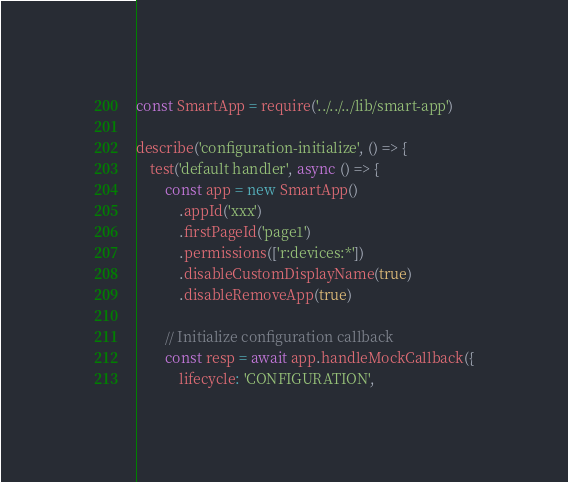Convert code to text. <code><loc_0><loc_0><loc_500><loc_500><_JavaScript_>const SmartApp = require('../../../lib/smart-app')

describe('configuration-initialize', () => {
	test('default handler', async () => {
		const app = new SmartApp()
			.appId('xxx')
			.firstPageId('page1')
			.permissions(['r:devices:*'])
			.disableCustomDisplayName(true)
			.disableRemoveApp(true)

		// Initialize configuration callback
		const resp = await app.handleMockCallback({
			lifecycle: 'CONFIGURATION',</code> 